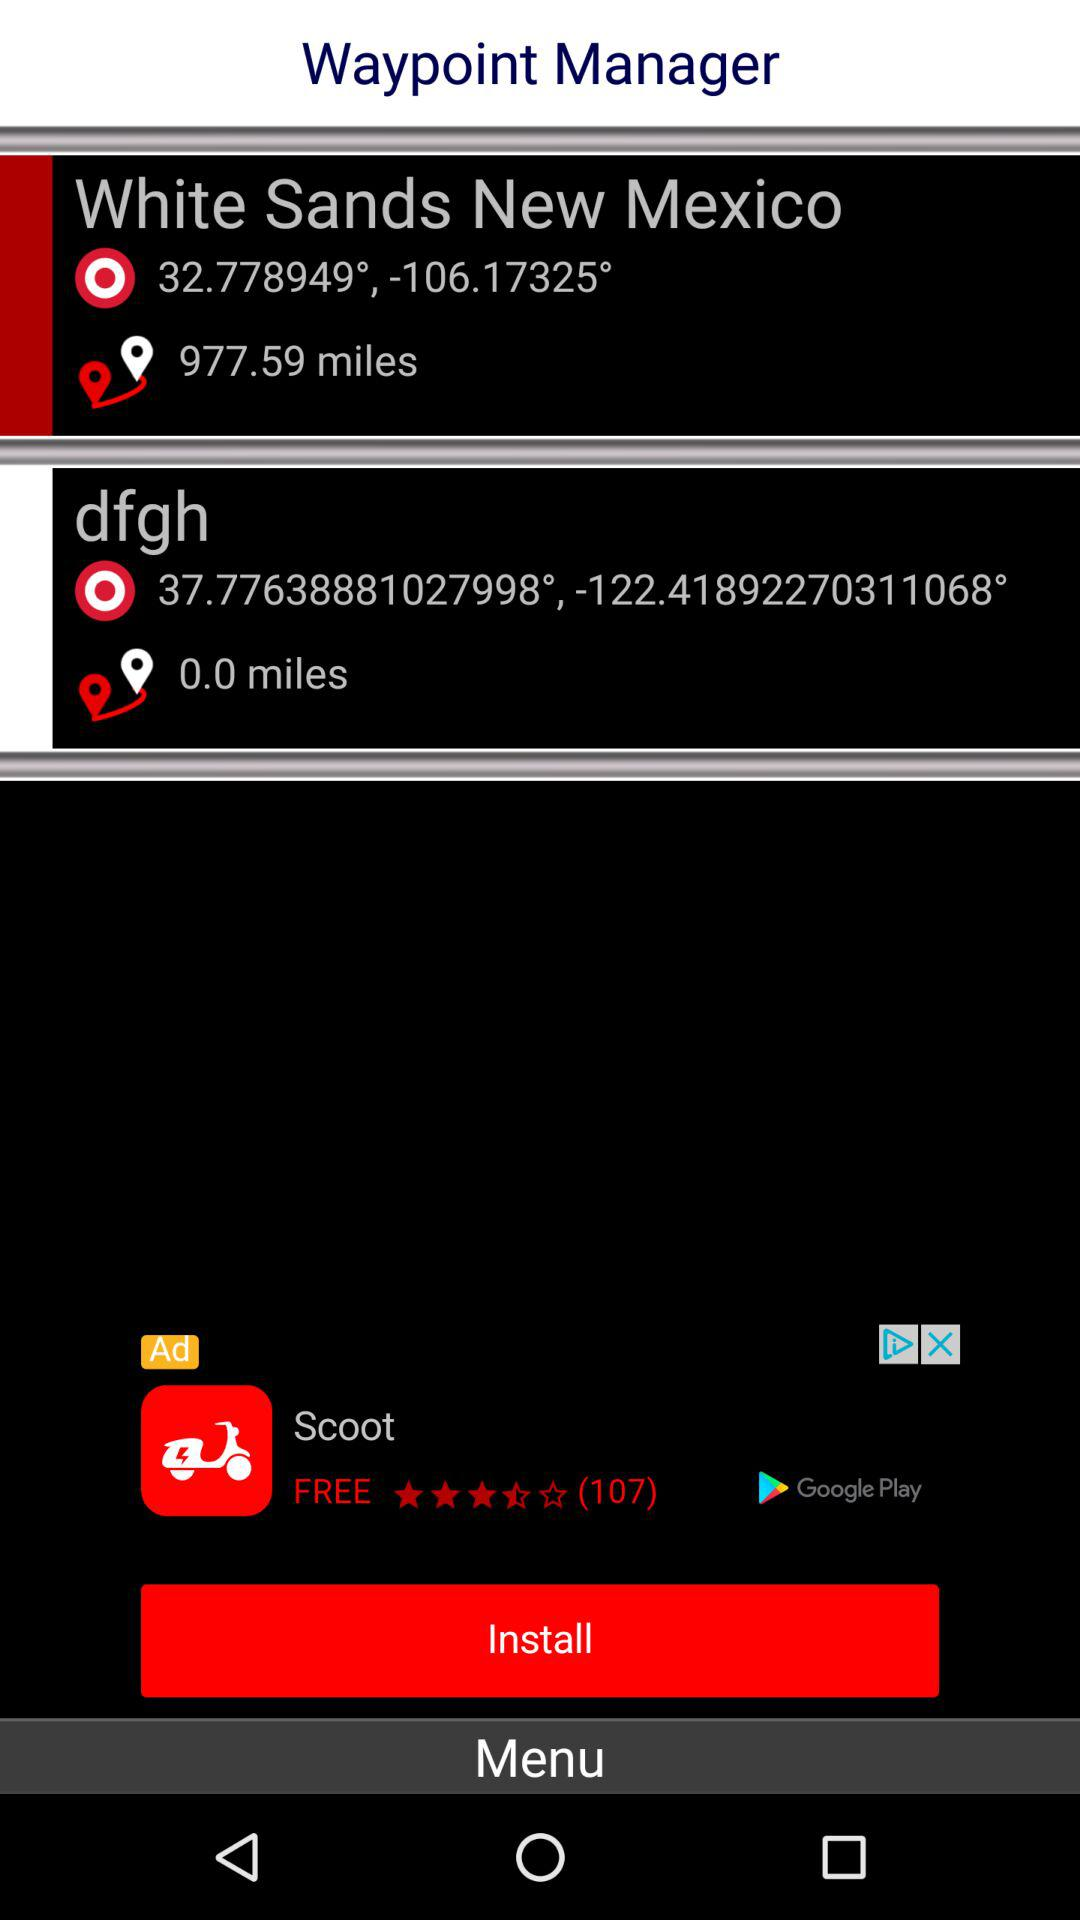What is the distance of White Sands New Mexico? The distance is 977.59 miles. 